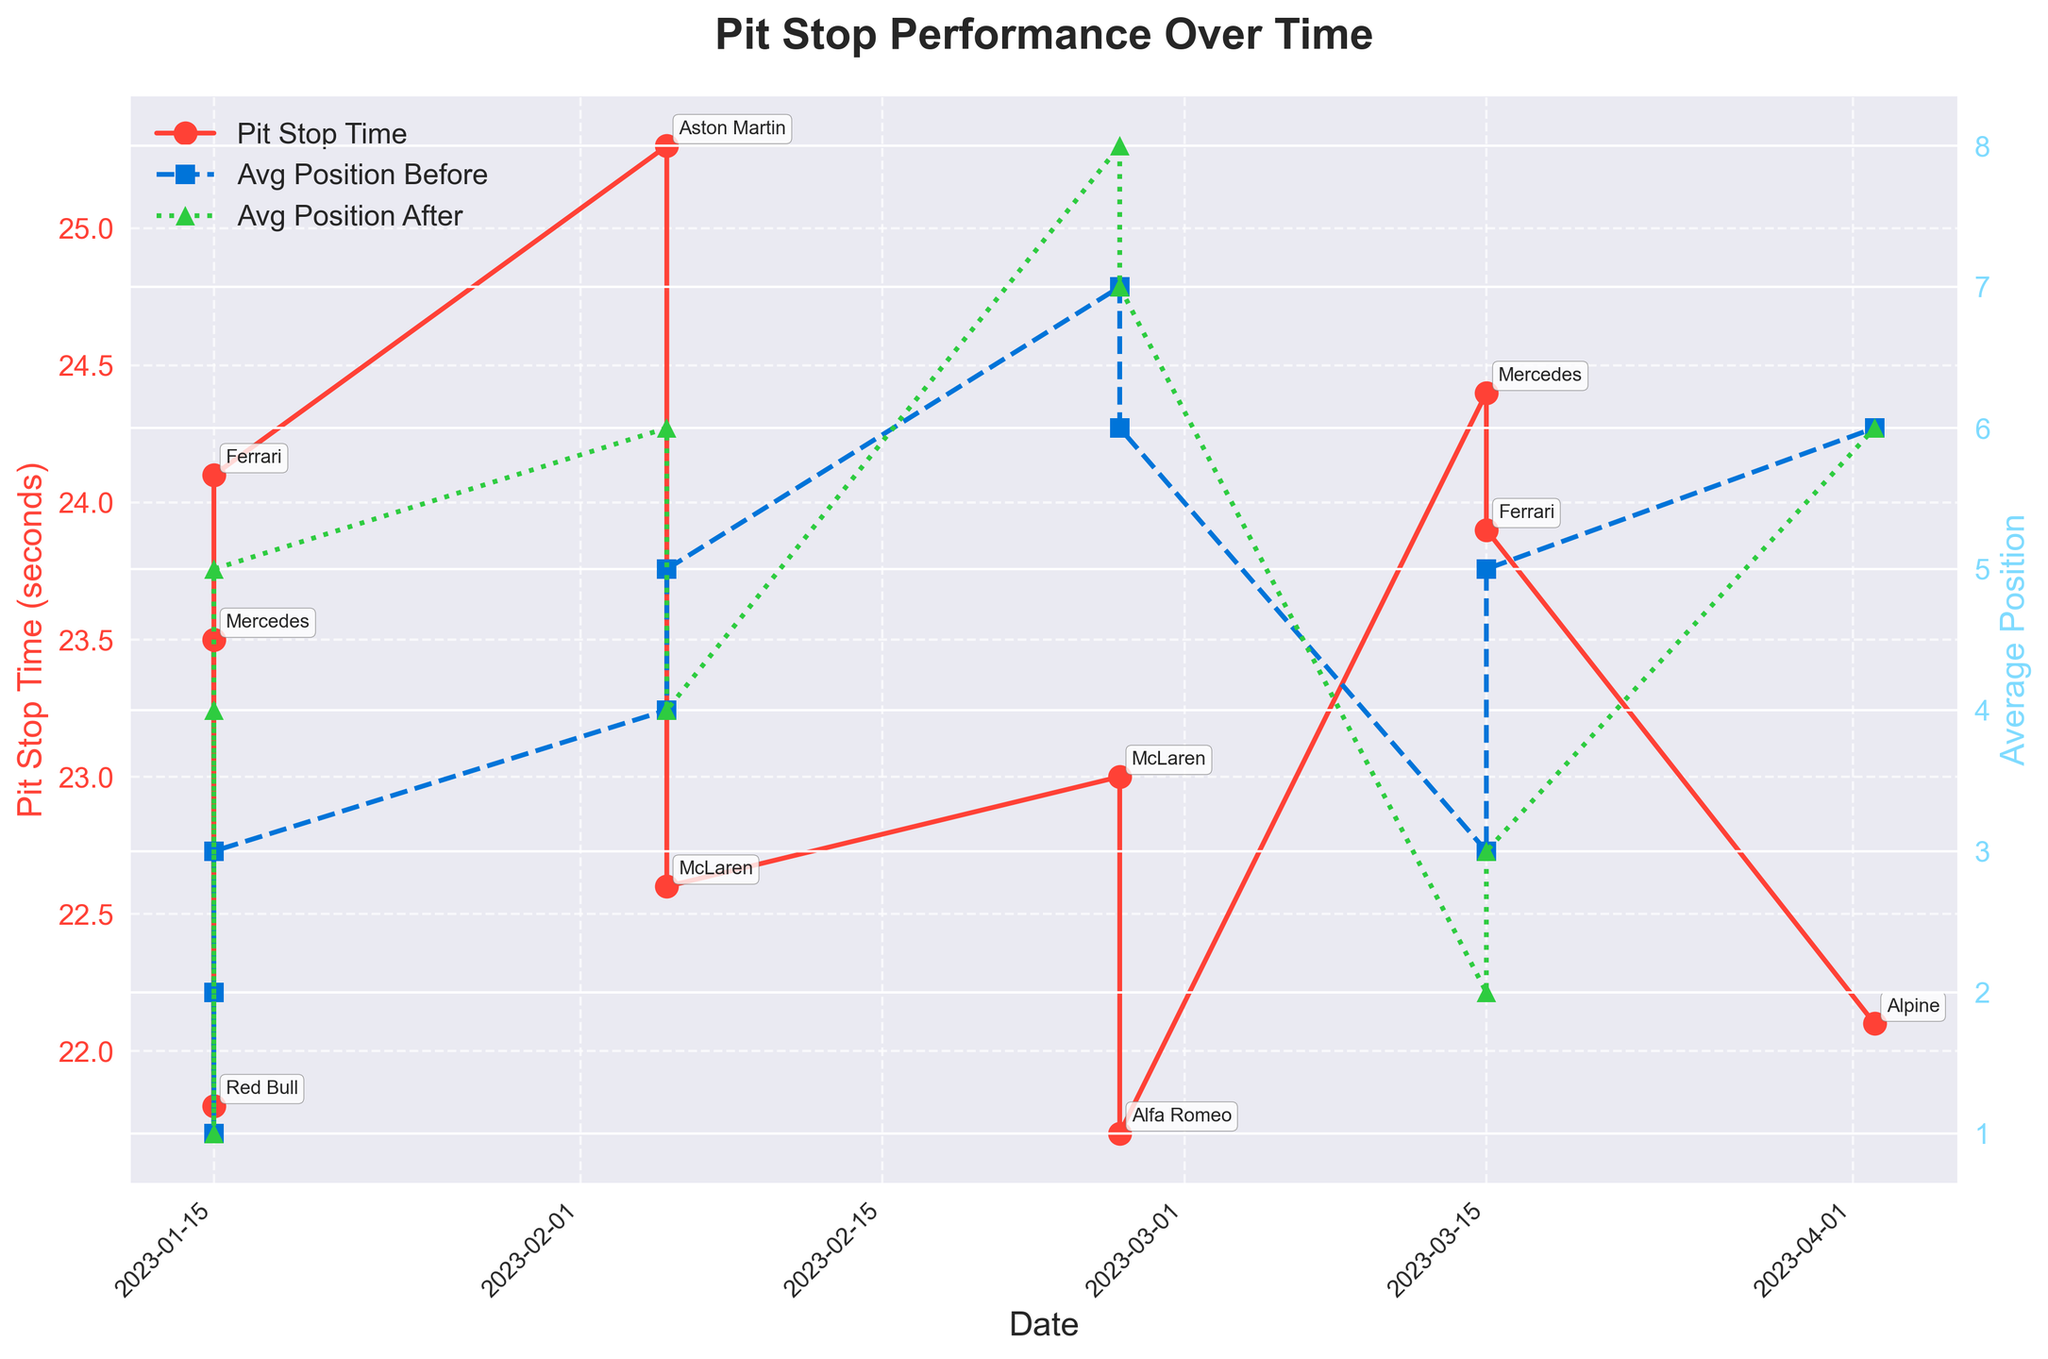What's the title of the plot? The title of the plot is displayed at the top and reads 'Pit Stop Performance Over Time'.
Answer: Pit Stop Performance Over Time What is the color used for the line representing 'Pit Stop Time'? The line for 'Pit Stop Time' is shown with a red color.
Answer: Red Which date had the fastest pit stop time? By looking at the 'Pit Stop Time' data points on the plot, the point with the lowest value corresponds to 2023-02-26.
Answer: 2023-02-26 What was the average position before the pit stop for George Russell? Find the point labeled 'George Russell' on the plot and look at the value on the second y-axis (Average Position) before the pit stop; it shows 3.
Answer: 3 Between which two drivers is there the largest difference in pit stop time on the same date? On 2023-01-15, the pit stop times for Lewis Hamilton and Max Verstappen are compared, showing the largest difference of 23.5 - 21.8 = 1.7 seconds.
Answer: Lewis Hamilton and Max Verstappen How did Sebastian Vettel's position change after his pit stop on 2023-02-05? Look at the two lines for 'Average Position Before Pit Stop' and 'Average Position After Pit Stop' for 2023-02-05 where Sebastian Vettel's change is seen from 4 to 6.
Answer: From 4 to 6 Who had a position improvement post-pit stop on 2023-03-15? On 2023-03-15, George Russell improved his position from 3 to 2 after the pit stop.
Answer: George Russell Which driver had the poorest final race position and what was it? By looking at the figure and finding the driver with the highest final race position number, Valtteri Bottas with a position of 8 can be identified.
Answer: Valtteri Bottas, 8 What is the difference in positions before and after the pit stop for Carlos Sainz on 2023-03-15? Carlos Sainz's position difference is found by subtracting the value for 'Average Position After Pit Stop' from 'Average Position Before Pit Stop,' giving 5 - 3 = 2.
Answer: 2 Which Team Name had a pit stop time annotation closest to 22 seconds? The annotation for 'Pierre Gasly' on the plot near the 22-second mark indicates the 'Alpine' team.
Answer: Alpine 